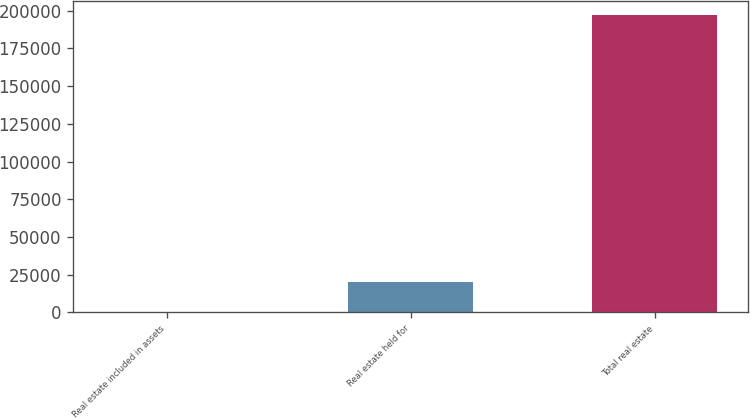Convert chart. <chart><loc_0><loc_0><loc_500><loc_500><bar_chart><fcel>Real estate included in assets<fcel>Real estate held for<fcel>Total real estate<nl><fcel>248<fcel>19908.3<fcel>196851<nl></chart> 